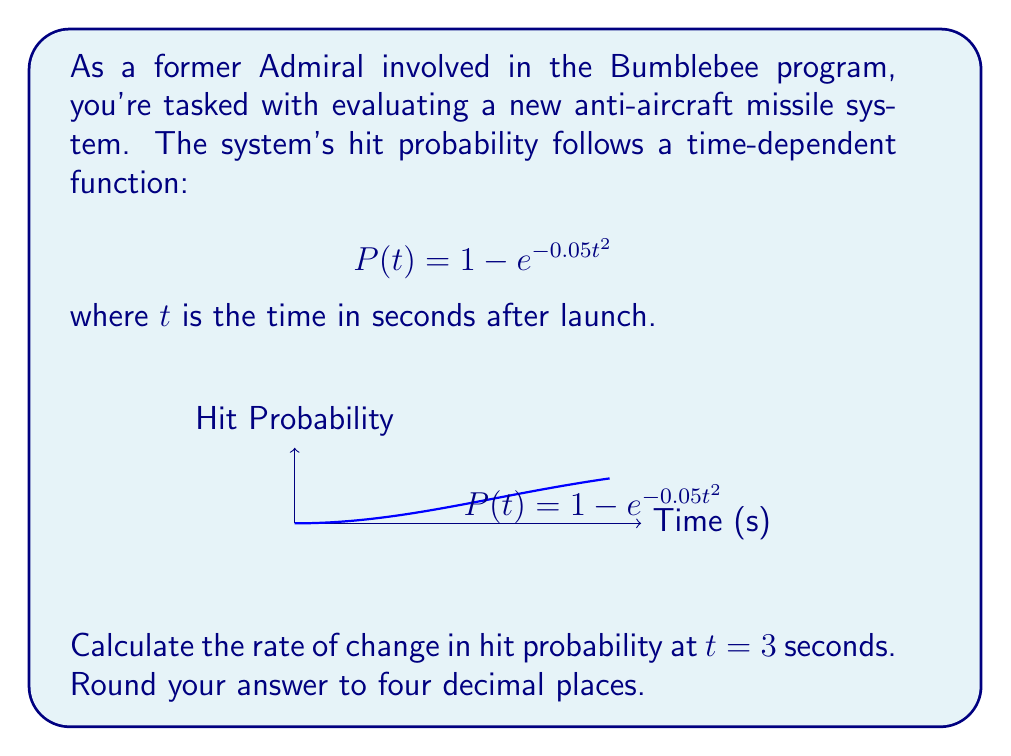Teach me how to tackle this problem. To solve this problem, we need to follow these steps:

1) The hit probability function is given as:
   $$P(t) = 1 - e^{-0.05t^2}$$

2) To find the rate of change, we need to differentiate $P(t)$ with respect to $t$:
   $$\frac{dP}{dt} = \frac{d}{dt}(1 - e^{-0.05t^2})$$

3) Using the chain rule:
   $$\frac{dP}{dt} = -e^{-0.05t^2} \cdot \frac{d}{dt}(-0.05t^2)$$

4) Simplify:
   $$\frac{dP}{dt} = -e^{-0.05t^2} \cdot (-0.1t)$$
   $$\frac{dP}{dt} = 0.1t \cdot e^{-0.05t^2}$$

5) Now, we need to evaluate this at $t = 3$:
   $$\left.\frac{dP}{dt}\right|_{t=3} = 0.1 \cdot 3 \cdot e^{-0.05 \cdot 3^2}$$

6) Calculate:
   $$\left.\frac{dP}{dt}\right|_{t=3} = 0.3 \cdot e^{-0.45} \approx 0.1907$$

7) Rounding to four decimal places:
   $$\left.\frac{dP}{dt}\right|_{t=3} \approx 0.1907$$
Answer: 0.1907 